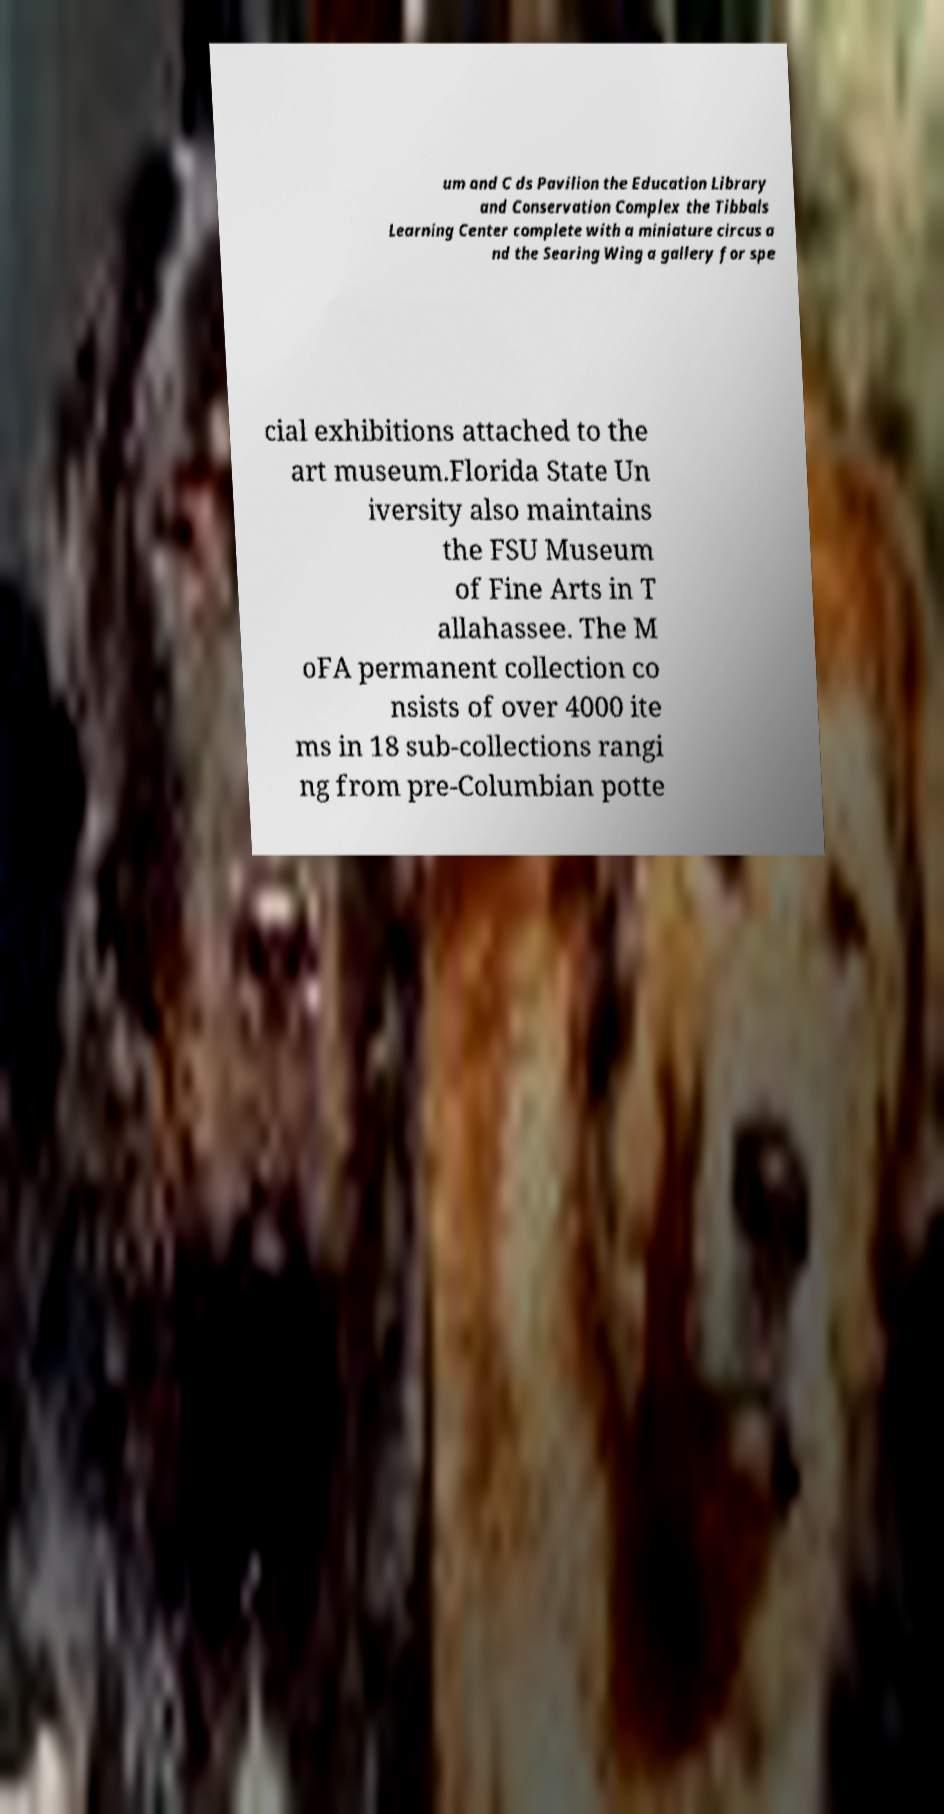There's text embedded in this image that I need extracted. Can you transcribe it verbatim? um and C ds Pavilion the Education Library and Conservation Complex the Tibbals Learning Center complete with a miniature circus a nd the Searing Wing a gallery for spe cial exhibitions attached to the art museum.Florida State Un iversity also maintains the FSU Museum of Fine Arts in T allahassee. The M oFA permanent collection co nsists of over 4000 ite ms in 18 sub-collections rangi ng from pre-Columbian potte 